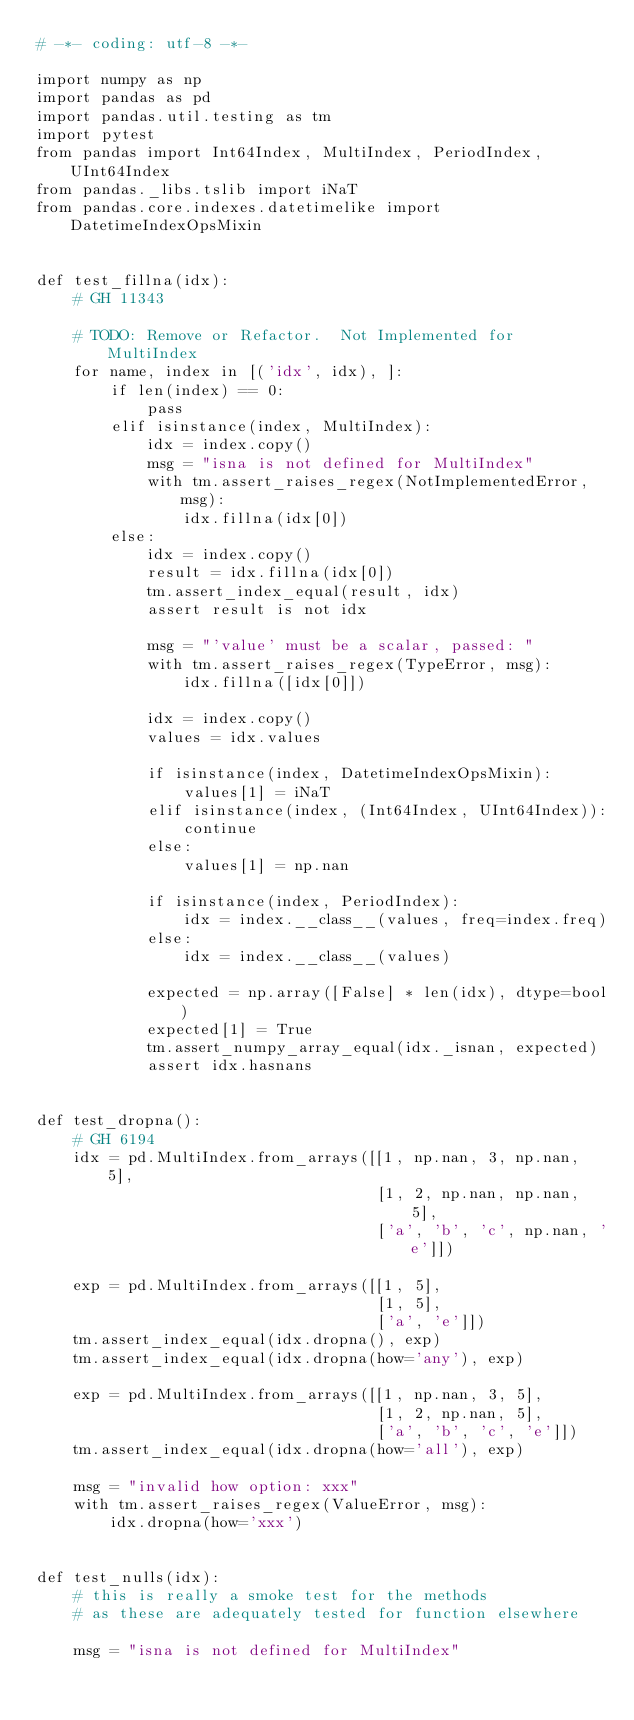<code> <loc_0><loc_0><loc_500><loc_500><_Python_># -*- coding: utf-8 -*-

import numpy as np
import pandas as pd
import pandas.util.testing as tm
import pytest
from pandas import Int64Index, MultiIndex, PeriodIndex, UInt64Index
from pandas._libs.tslib import iNaT
from pandas.core.indexes.datetimelike import DatetimeIndexOpsMixin


def test_fillna(idx):
    # GH 11343

    # TODO: Remove or Refactor.  Not Implemented for MultiIndex
    for name, index in [('idx', idx), ]:
        if len(index) == 0:
            pass
        elif isinstance(index, MultiIndex):
            idx = index.copy()
            msg = "isna is not defined for MultiIndex"
            with tm.assert_raises_regex(NotImplementedError, msg):
                idx.fillna(idx[0])
        else:
            idx = index.copy()
            result = idx.fillna(idx[0])
            tm.assert_index_equal(result, idx)
            assert result is not idx

            msg = "'value' must be a scalar, passed: "
            with tm.assert_raises_regex(TypeError, msg):
                idx.fillna([idx[0]])

            idx = index.copy()
            values = idx.values

            if isinstance(index, DatetimeIndexOpsMixin):
                values[1] = iNaT
            elif isinstance(index, (Int64Index, UInt64Index)):
                continue
            else:
                values[1] = np.nan

            if isinstance(index, PeriodIndex):
                idx = index.__class__(values, freq=index.freq)
            else:
                idx = index.__class__(values)

            expected = np.array([False] * len(idx), dtype=bool)
            expected[1] = True
            tm.assert_numpy_array_equal(idx._isnan, expected)
            assert idx.hasnans


def test_dropna():
    # GH 6194
    idx = pd.MultiIndex.from_arrays([[1, np.nan, 3, np.nan, 5],
                                     [1, 2, np.nan, np.nan, 5],
                                     ['a', 'b', 'c', np.nan, 'e']])

    exp = pd.MultiIndex.from_arrays([[1, 5],
                                     [1, 5],
                                     ['a', 'e']])
    tm.assert_index_equal(idx.dropna(), exp)
    tm.assert_index_equal(idx.dropna(how='any'), exp)

    exp = pd.MultiIndex.from_arrays([[1, np.nan, 3, 5],
                                     [1, 2, np.nan, 5],
                                     ['a', 'b', 'c', 'e']])
    tm.assert_index_equal(idx.dropna(how='all'), exp)

    msg = "invalid how option: xxx"
    with tm.assert_raises_regex(ValueError, msg):
        idx.dropna(how='xxx')


def test_nulls(idx):
    # this is really a smoke test for the methods
    # as these are adequately tested for function elsewhere

    msg = "isna is not defined for MultiIndex"</code> 